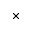<formula> <loc_0><loc_0><loc_500><loc_500>\times</formula> 